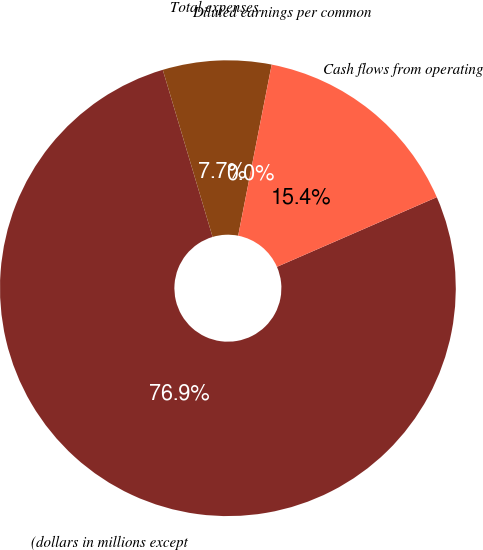<chart> <loc_0><loc_0><loc_500><loc_500><pie_chart><fcel>(dollars in millions except<fcel>Total expenses<fcel>Diluted earnings per common<fcel>Cash flows from operating<nl><fcel>76.92%<fcel>7.69%<fcel>0.0%<fcel>15.38%<nl></chart> 